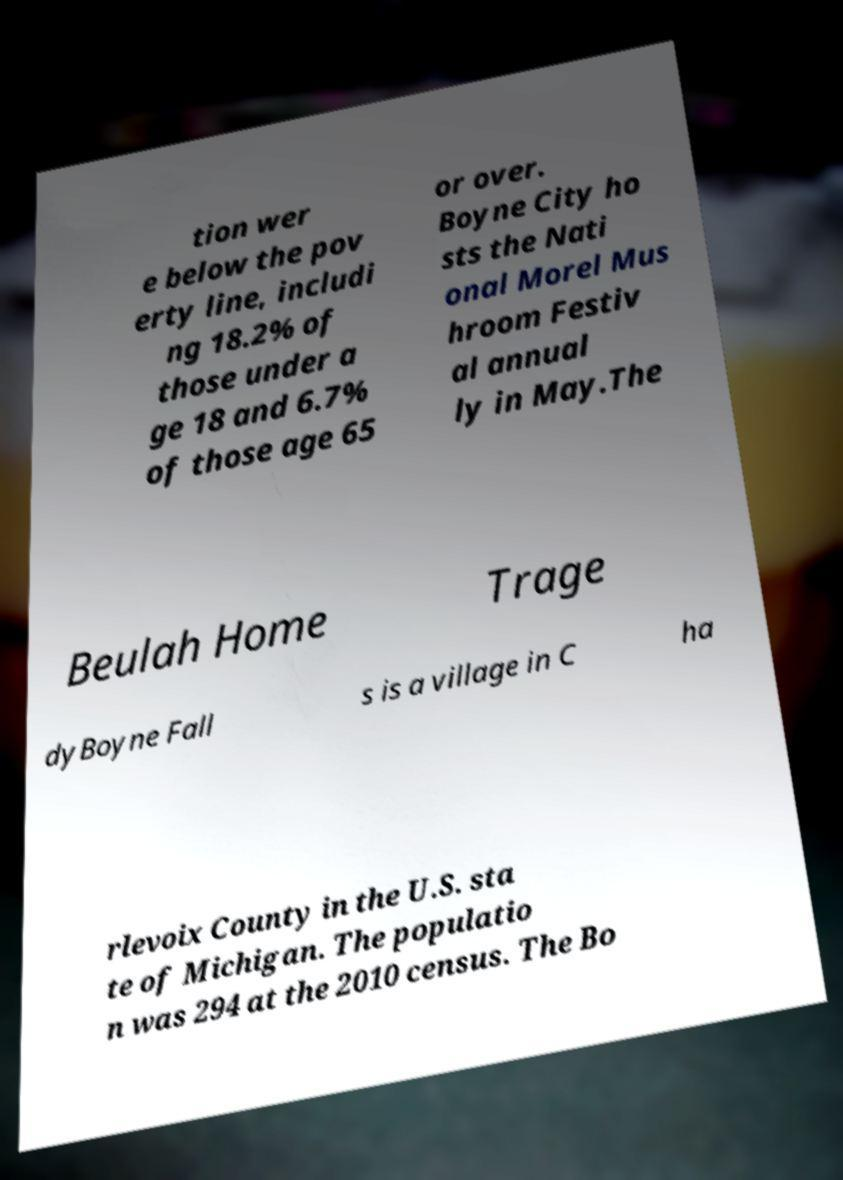Could you assist in decoding the text presented in this image and type it out clearly? tion wer e below the pov erty line, includi ng 18.2% of those under a ge 18 and 6.7% of those age 65 or over. Boyne City ho sts the Nati onal Morel Mus hroom Festiv al annual ly in May.The Beulah Home Trage dyBoyne Fall s is a village in C ha rlevoix County in the U.S. sta te of Michigan. The populatio n was 294 at the 2010 census. The Bo 